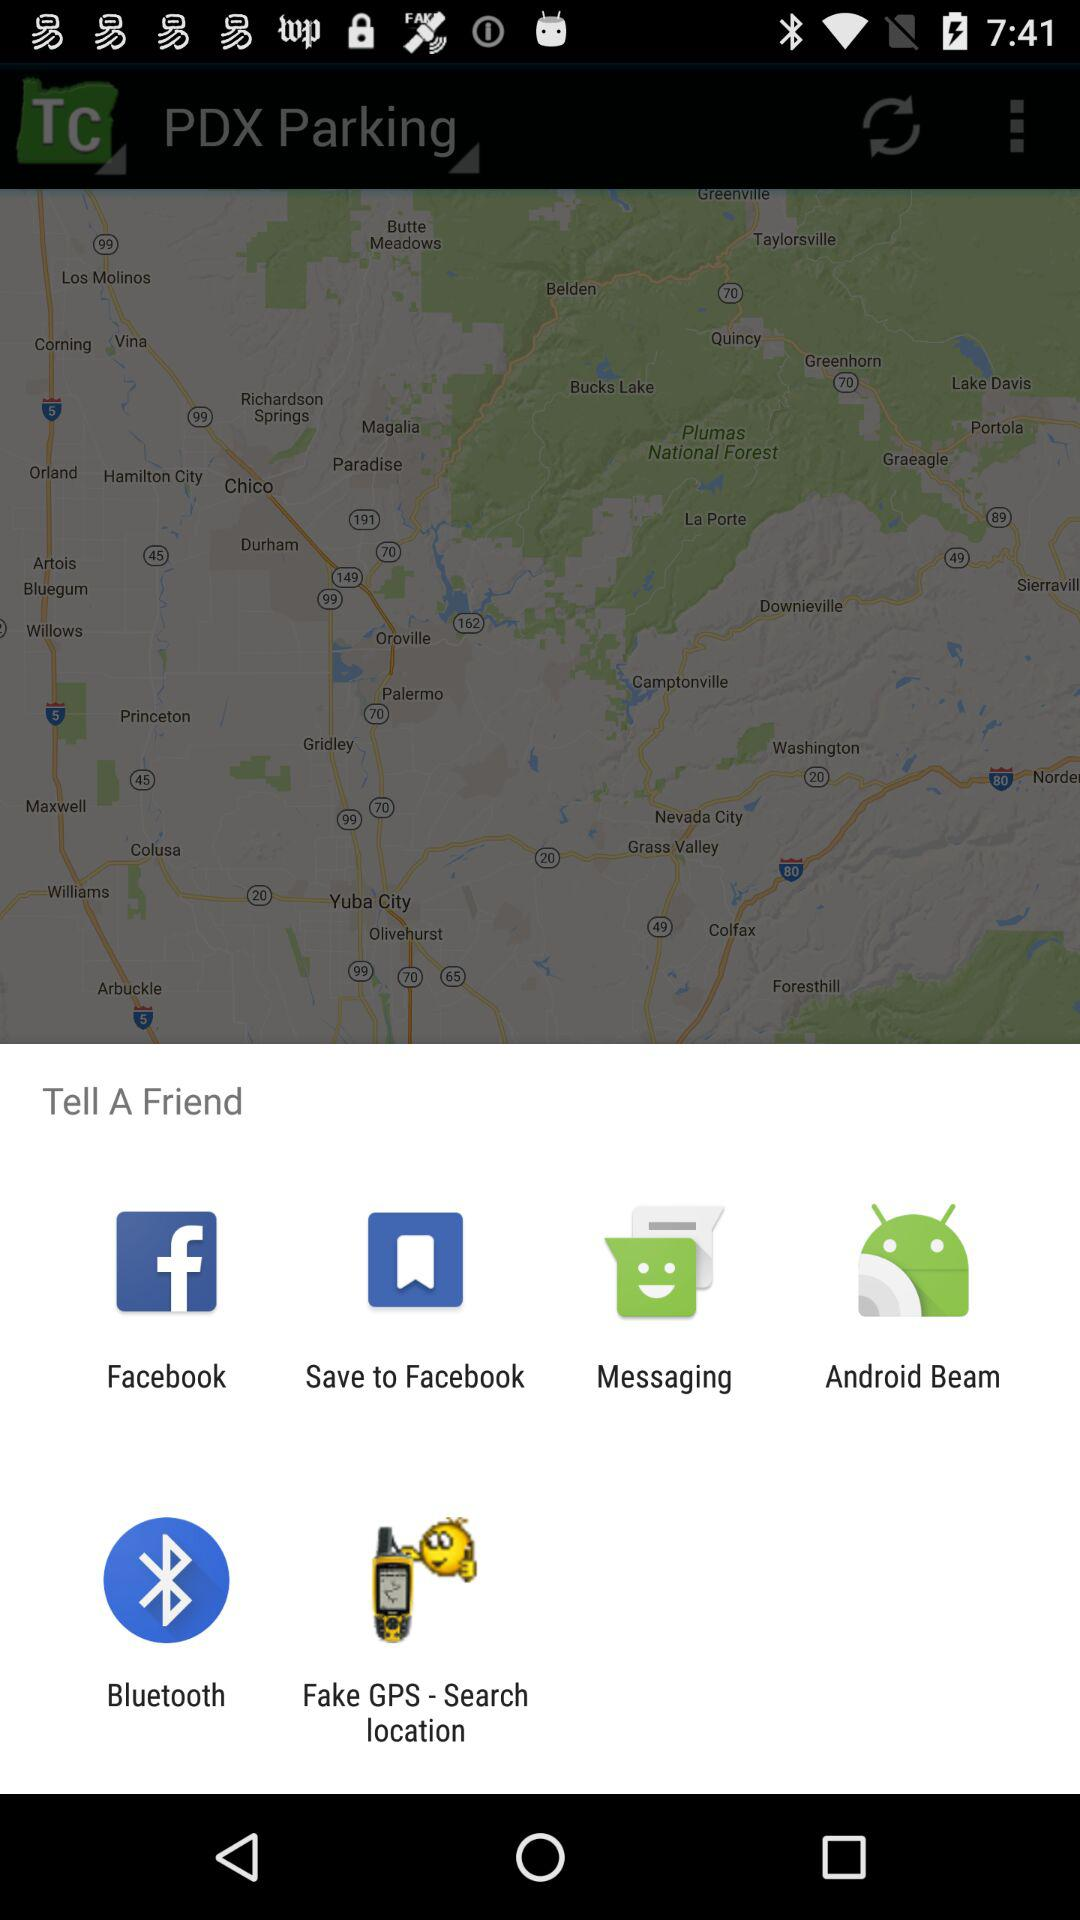What are the different mediums to tell a friend? The different mediums are "Facebook", "Save to Facebook", "Messaging", "Android Beam", "Bluetooth" and "Fake GPS - Search location". 